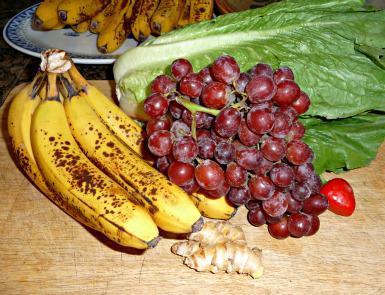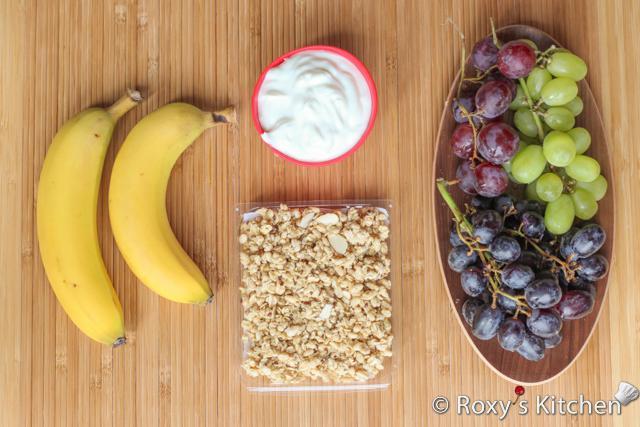The first image is the image on the left, the second image is the image on the right. Assess this claim about the two images: "There are red grapes and green grapes beside each-other in one of the images.". Correct or not? Answer yes or no. Yes. The first image is the image on the left, the second image is the image on the right. Given the left and right images, does the statement "One of the images has at least one apple." hold true? Answer yes or no. No. 